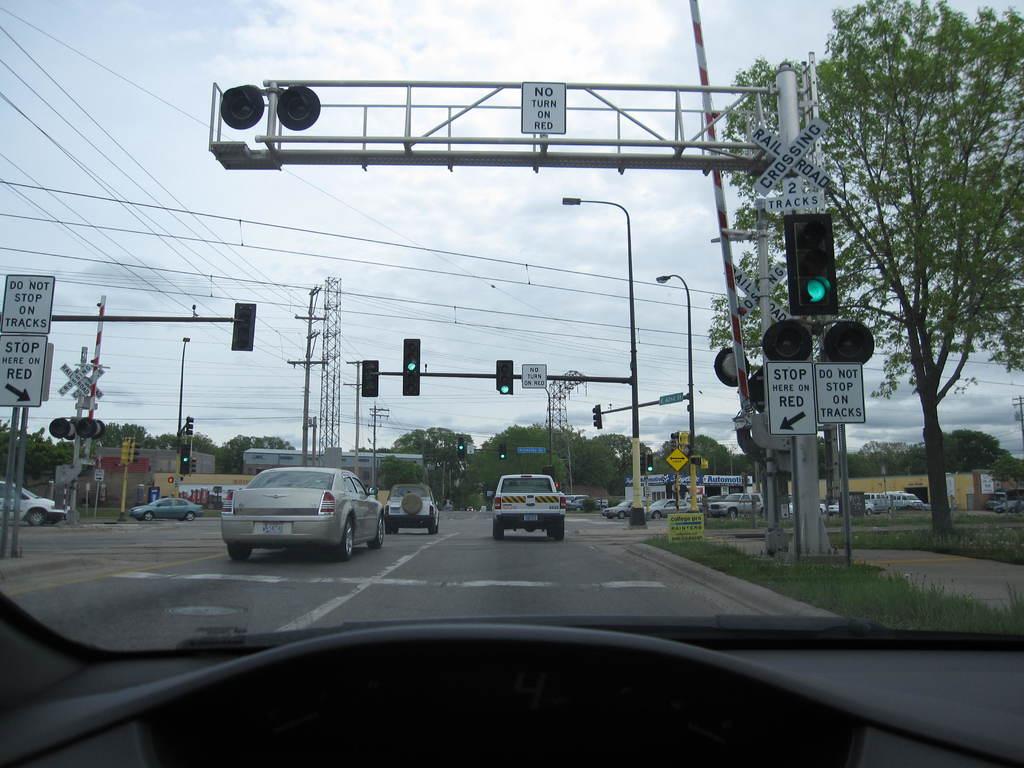What color is written on the signs?
Keep it short and to the point. Black. What does the sign with the arrow say?
Provide a succinct answer. Stop here on red. 